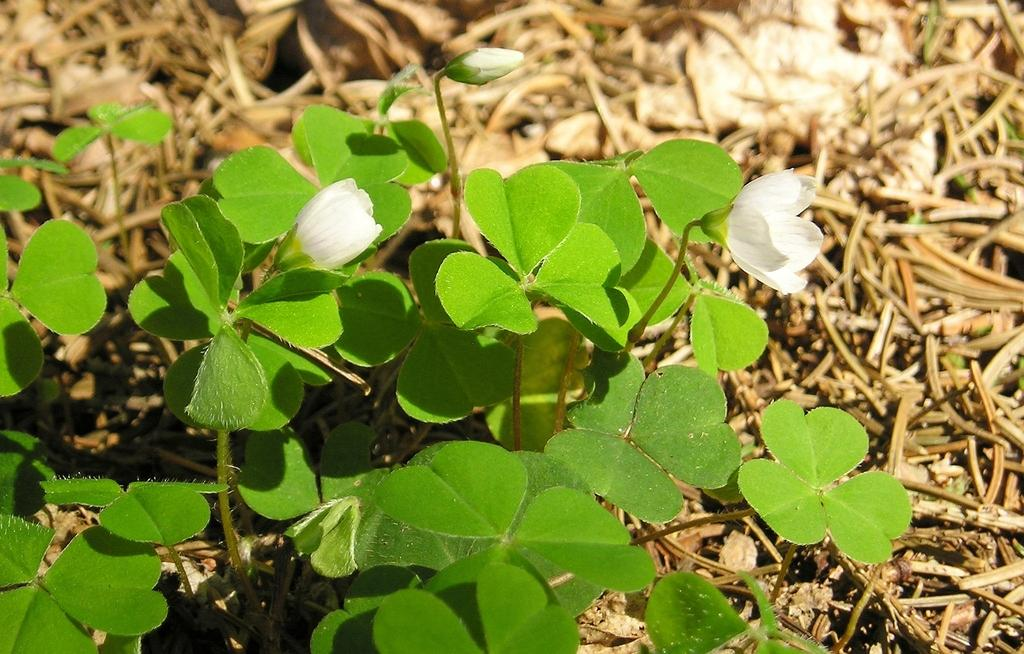What type of living organisms can be seen in the image? There are flowers and plants in the image. Can you describe the plants in the image? The plants in the image are not specified, but they are present alongside the flowers. What type of protest is happening in the image? There is no protest present in the image; it features flowers and plants. What type of produce is visible in the image? There is no produce visible in the image; it features flowers and plants. 